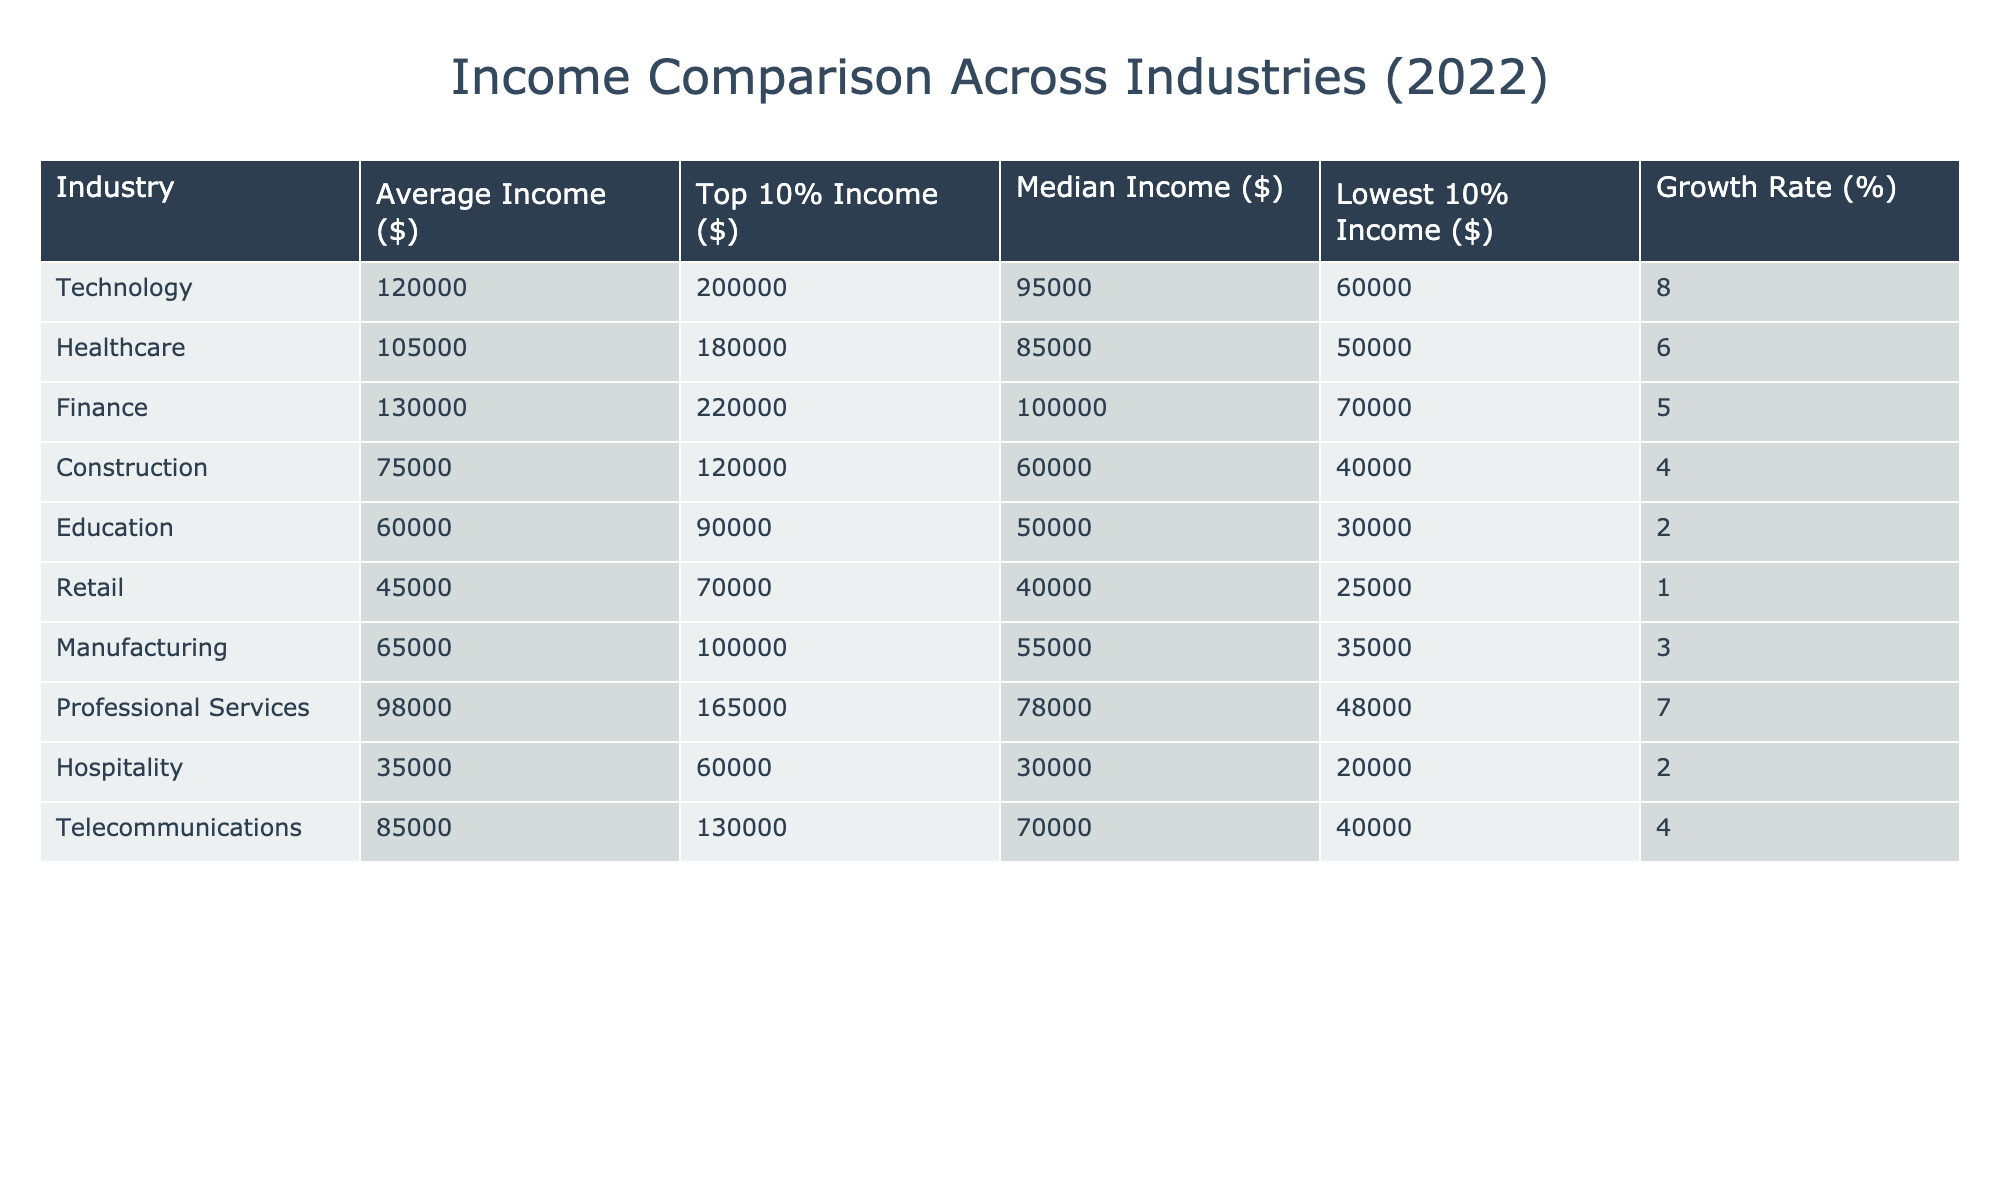What is the average income in the Finance industry? The average income for the Finance industry is listed directly in the table as $130,000.
Answer: 130000 Which industry has the lowest average income? The average income for each industry is listed, and the Retail industry has the lowest at $45,000.
Answer: Retail What is the difference between the average income of Technology and Education industries? The average income for Technology is $120,000, and for Education, it is $60,000. The difference is $120,000 - $60,000 = $60,000.
Answer: 60000 Is the median income in Healthcare higher than in Retail? The median income for Healthcare is $85,000, and for Retail, it is $40,000. Since $85,000 is greater than $40,000, the statement is true.
Answer: Yes Calculate the average growth rate of the industries listed. To find the average growth rate, sum the growth rates: 8 + 6 + 5 + 4 + 2 + 1 + 3 + 7 + 2 + 4 = 38. There are 10 industries, so the average is 38 / 10 = 3.8%.
Answer: 3.8 What percentage of industries have an average income above $100,000? The industries with an average income above $100,000 are Technology, Healthcare, and Finance, totaling 3 out of 10 industries. So the percentage is (3 / 10) * 100 = 30%.
Answer: 30% Which industry has the largest difference between the Top 10% income and the Lowest 10% income, and what is that difference? The Top 10% income and Lowest 10% income of each industry must be evaluated. The difference for Finance is $220,000 - $70,000 = $150,000. Checking other industries shows that Finance has the largest difference.
Answer: Finance, 150000 Is the top 10% income in Education greater than the top 10% income in Hospitality? The top 10% income in Education is $90,000, and in Hospitality it is $60,000. Since $90,000 is greater than $60,000, this statement is true.
Answer: Yes 